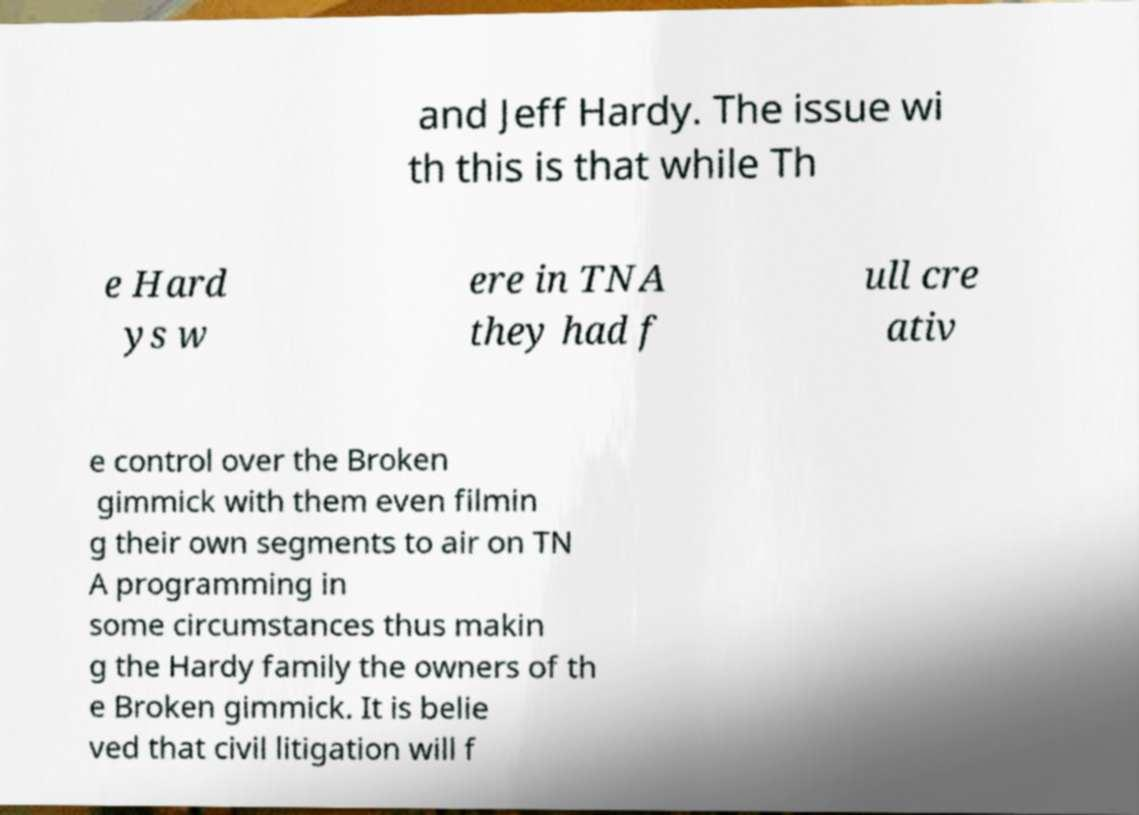What messages or text are displayed in this image? I need them in a readable, typed format. and Jeff Hardy. The issue wi th this is that while Th e Hard ys w ere in TNA they had f ull cre ativ e control over the Broken gimmick with them even filmin g their own segments to air on TN A programming in some circumstances thus makin g the Hardy family the owners of th e Broken gimmick. It is belie ved that civil litigation will f 